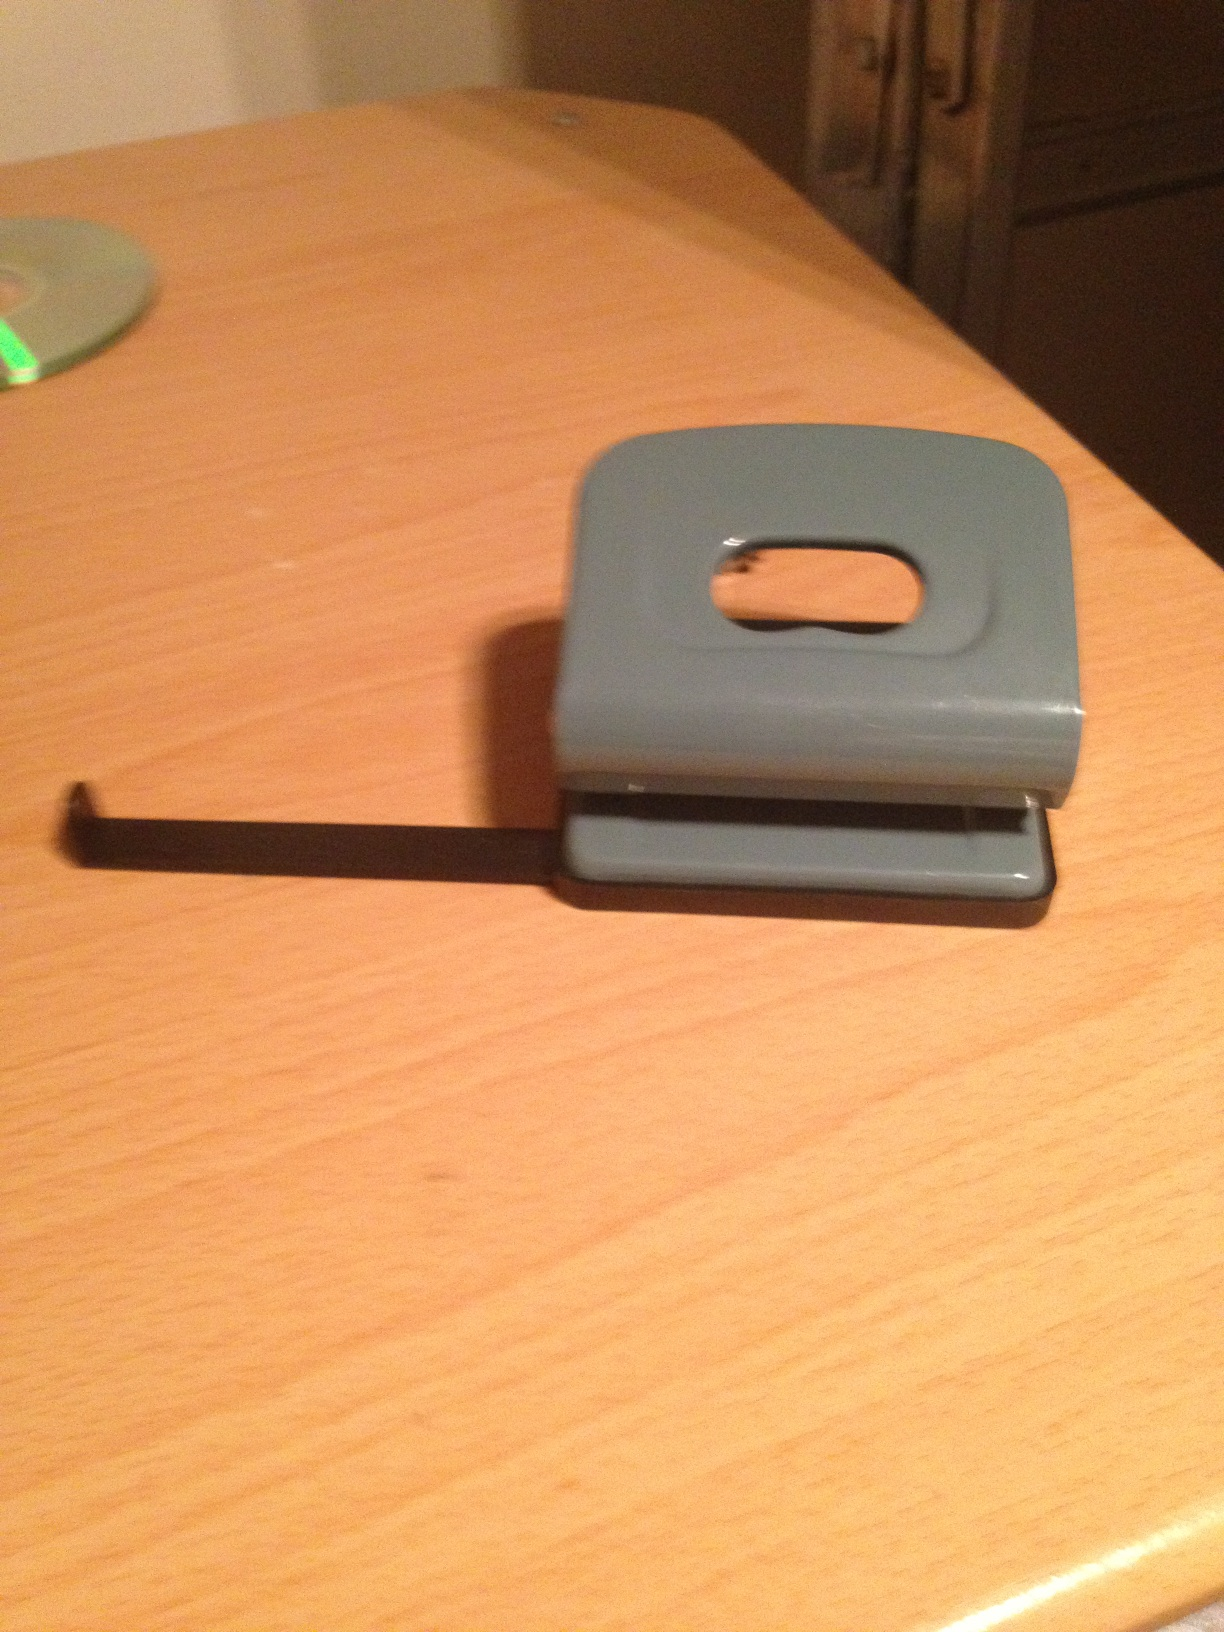How many holes does this punch make at once? This type of hole punch appears to be a single-hole punch model, designed to make one hole at a time in paper. 